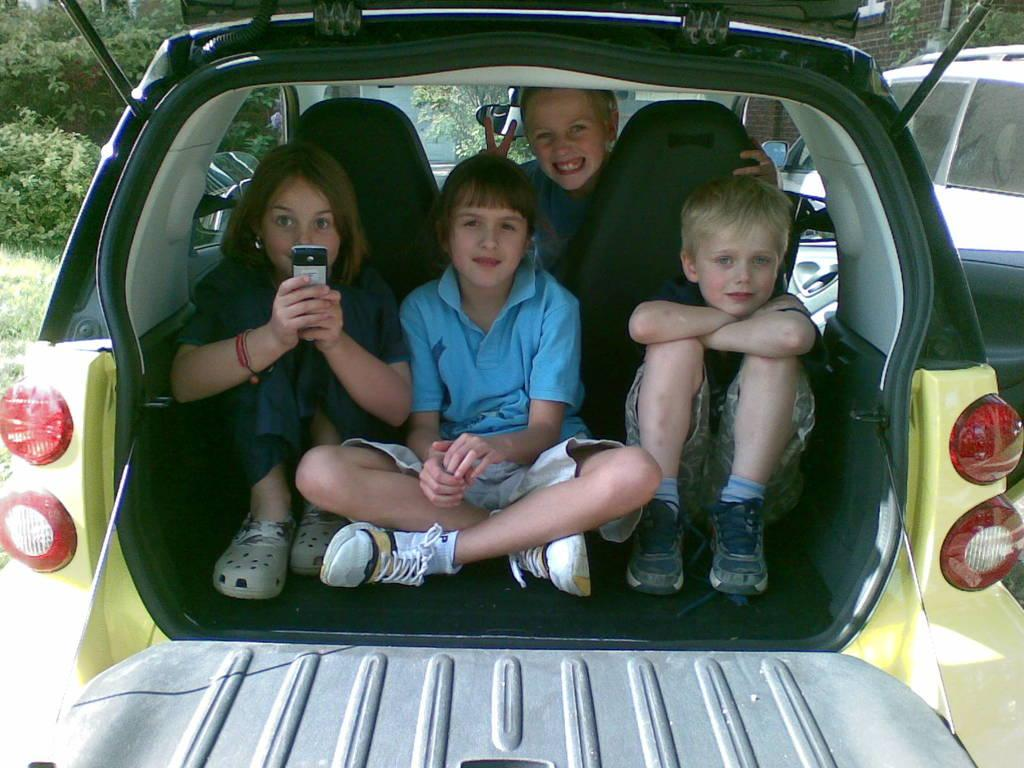What are the children doing in the image? The children are sitting inside a car. Can you describe the car in the image? There is a car in the background of the image. What else can be seen in the background of the image? There is a building and trees in the background of the image. What type of appliance is being used by the children in the image? There is no appliance visible in the image; the children are sitting inside a car. What food items are being consumed by the children in the image? There is no food visible in the image; the children are sitting inside a car. 